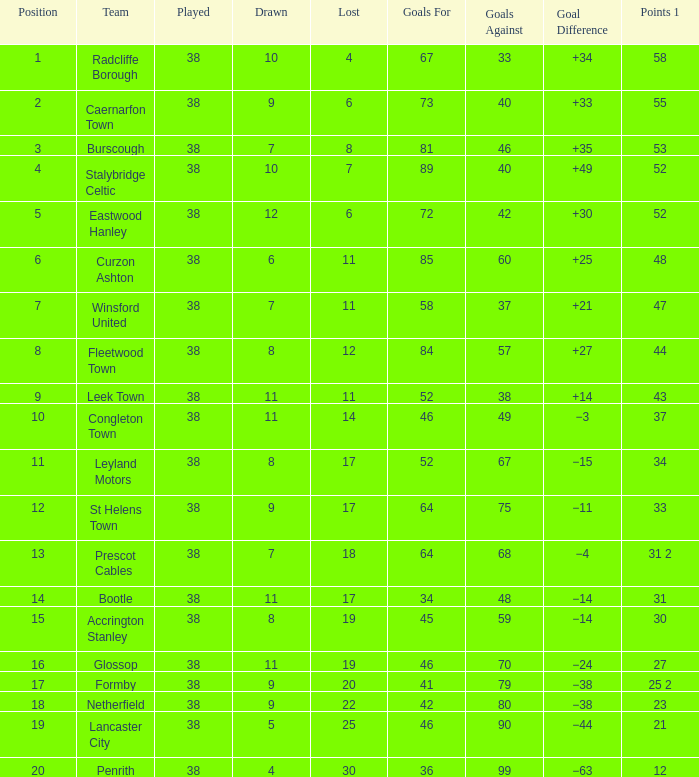What is the standing with a shortfall of 6, for caernarfon town? 2.0. Give me the full table as a dictionary. {'header': ['Position', 'Team', 'Played', 'Drawn', 'Lost', 'Goals For', 'Goals Against', 'Goal Difference', 'Points 1'], 'rows': [['1', 'Radcliffe Borough', '38', '10', '4', '67', '33', '+34', '58'], ['2', 'Caernarfon Town', '38', '9', '6', '73', '40', '+33', '55'], ['3', 'Burscough', '38', '7', '8', '81', '46', '+35', '53'], ['4', 'Stalybridge Celtic', '38', '10', '7', '89', '40', '+49', '52'], ['5', 'Eastwood Hanley', '38', '12', '6', '72', '42', '+30', '52'], ['6', 'Curzon Ashton', '38', '6', '11', '85', '60', '+25', '48'], ['7', 'Winsford United', '38', '7', '11', '58', '37', '+21', '47'], ['8', 'Fleetwood Town', '38', '8', '12', '84', '57', '+27', '44'], ['9', 'Leek Town', '38', '11', '11', '52', '38', '+14', '43'], ['10', 'Congleton Town', '38', '11', '14', '46', '49', '−3', '37'], ['11', 'Leyland Motors', '38', '8', '17', '52', '67', '−15', '34'], ['12', 'St Helens Town', '38', '9', '17', '64', '75', '−11', '33'], ['13', 'Prescot Cables', '38', '7', '18', '64', '68', '−4', '31 2'], ['14', 'Bootle', '38', '11', '17', '34', '48', '−14', '31'], ['15', 'Accrington Stanley', '38', '8', '19', '45', '59', '−14', '30'], ['16', 'Glossop', '38', '11', '19', '46', '70', '−24', '27'], ['17', 'Formby', '38', '9', '20', '41', '79', '−38', '25 2'], ['18', 'Netherfield', '38', '9', '22', '42', '80', '−38', '23'], ['19', 'Lancaster City', '38', '5', '25', '46', '90', '−44', '21'], ['20', 'Penrith', '38', '4', '30', '36', '99', '−63', '12']]} 